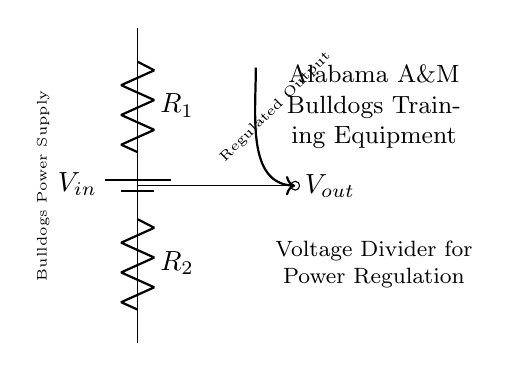What is the input voltage in this circuit? The input voltage, denoted as V_in, is represented by the battery symbol in the circuit. It is the voltage supplied to the voltage divider.
Answer: V_in What is the purpose of the resistors R_1 and R_2? Resistors R_1 and R_2 in a voltage divider circuit serve to divide the input voltage into a lower output voltage. The ratio of their values determines the output voltage.
Answer: To divide voltage What is V_out in this circuit? V_out is the regulated output voltage obtained from the voltage divider, measured at the junction between R_1 and R_2. It is specifically mentioned as an output in the diagram.
Answer: V_out How many resistors are used in this voltage divider? The diagram clearly shows two resistors, R_1 and R_2, connected in series within the voltage divider.
Answer: Two What is the relationship between R_1, R_2, and V_out? The relationship can be described by the formula V_out = V_in * (R_2 / (R_1 + R_2)), which shows how the resistor values control the output voltage.
Answer: V_out = V_in * (R_2 / (R_1 + R_2)) What does the label "Regulated Output" refer to in this circuit? The label indicates that the output voltage (V_out) is regulated based on the values of the resistors R_1 and R_2, providing a stable voltage for the training equipment.
Answer: Output voltage 